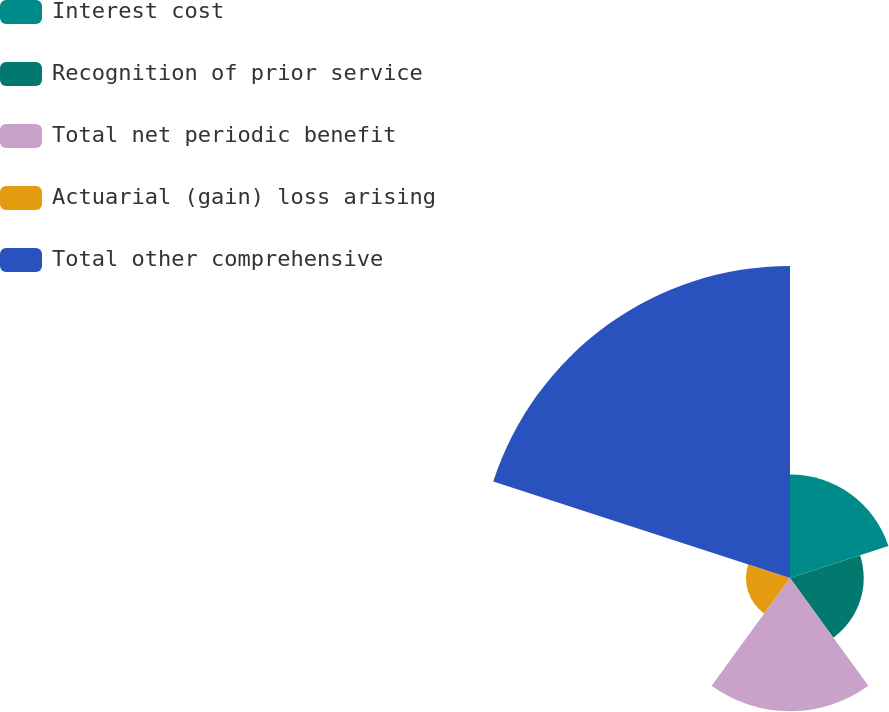Convert chart to OTSL. <chart><loc_0><loc_0><loc_500><loc_500><pie_chart><fcel>Interest cost<fcel>Recognition of prior service<fcel>Total net periodic benefit<fcel>Actuarial (gain) loss arising<fcel>Total other comprehensive<nl><fcel>15.53%<fcel>11.06%<fcel>20.0%<fcel>6.6%<fcel>46.81%<nl></chart> 